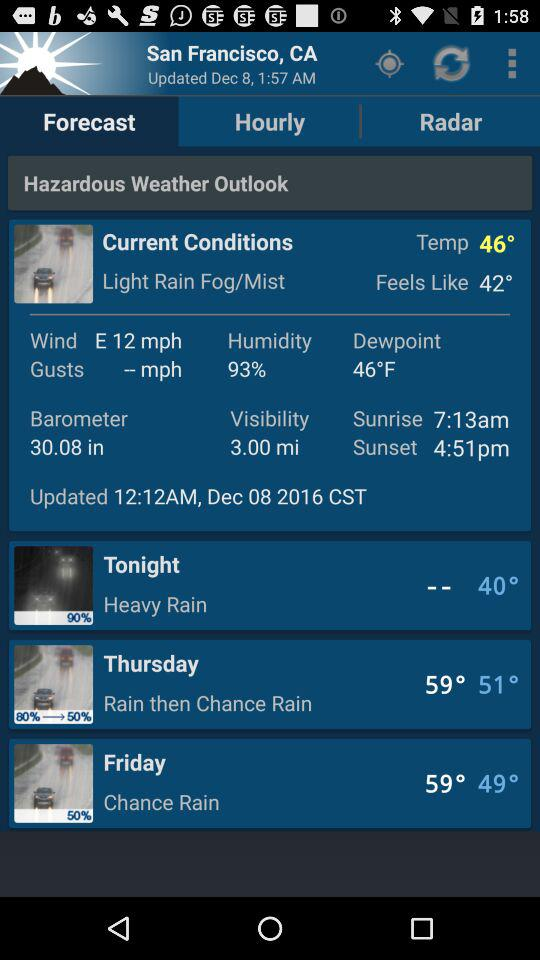What is the current temperature? The current temperature is "46°". 